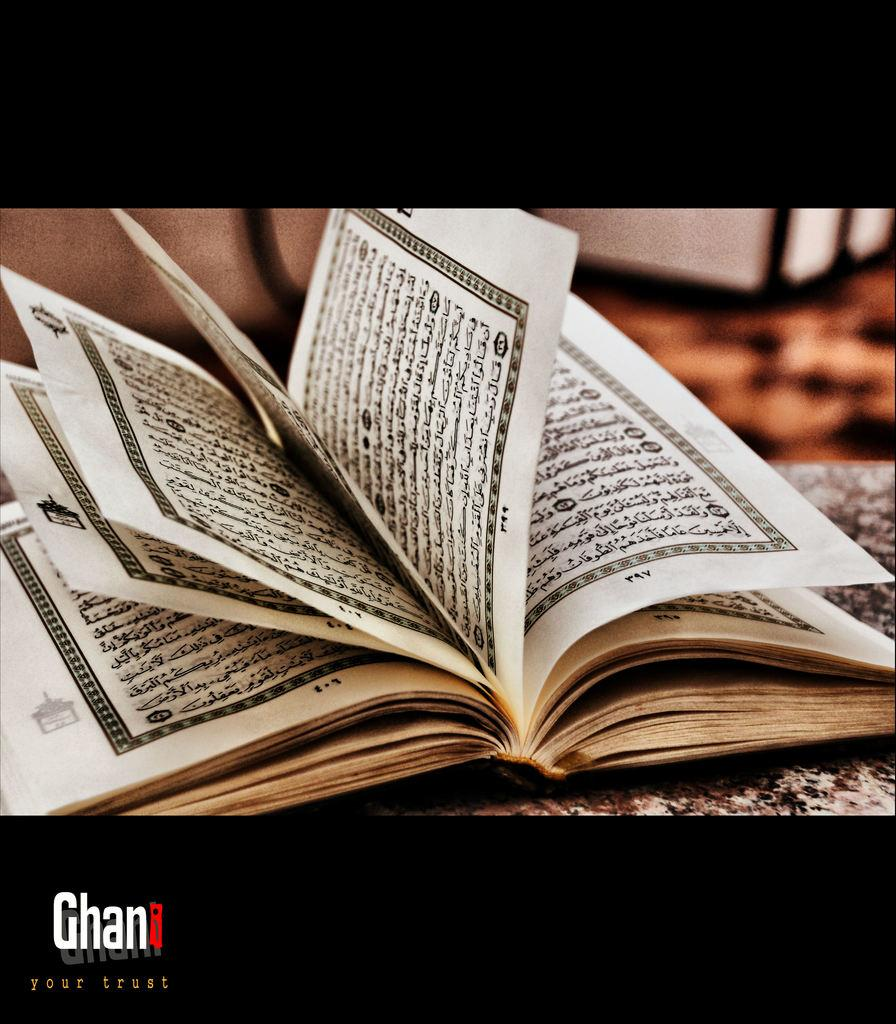What object can be seen in the image? There is a book in the image. Where is the book located? The book is on a surface. Can you describe any text visible in the image? There is text visible at the bottom of the image. How many cacti are present in the image? There are no cacti visible in the image. What is the temper of the book in the image? The book does not have a temper, as it is an inanimate object. 